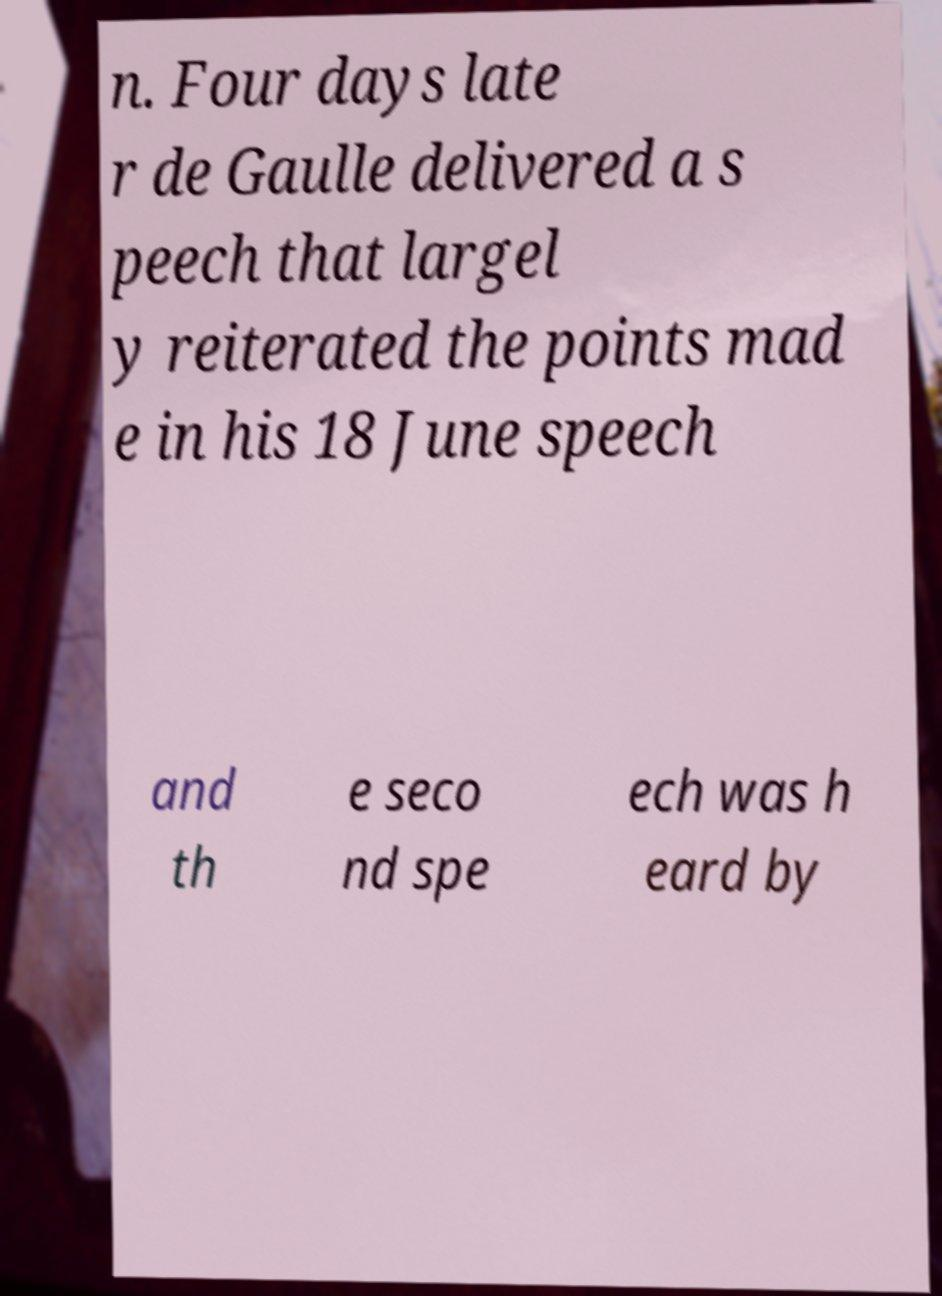Please identify and transcribe the text found in this image. n. Four days late r de Gaulle delivered a s peech that largel y reiterated the points mad e in his 18 June speech and th e seco nd spe ech was h eard by 